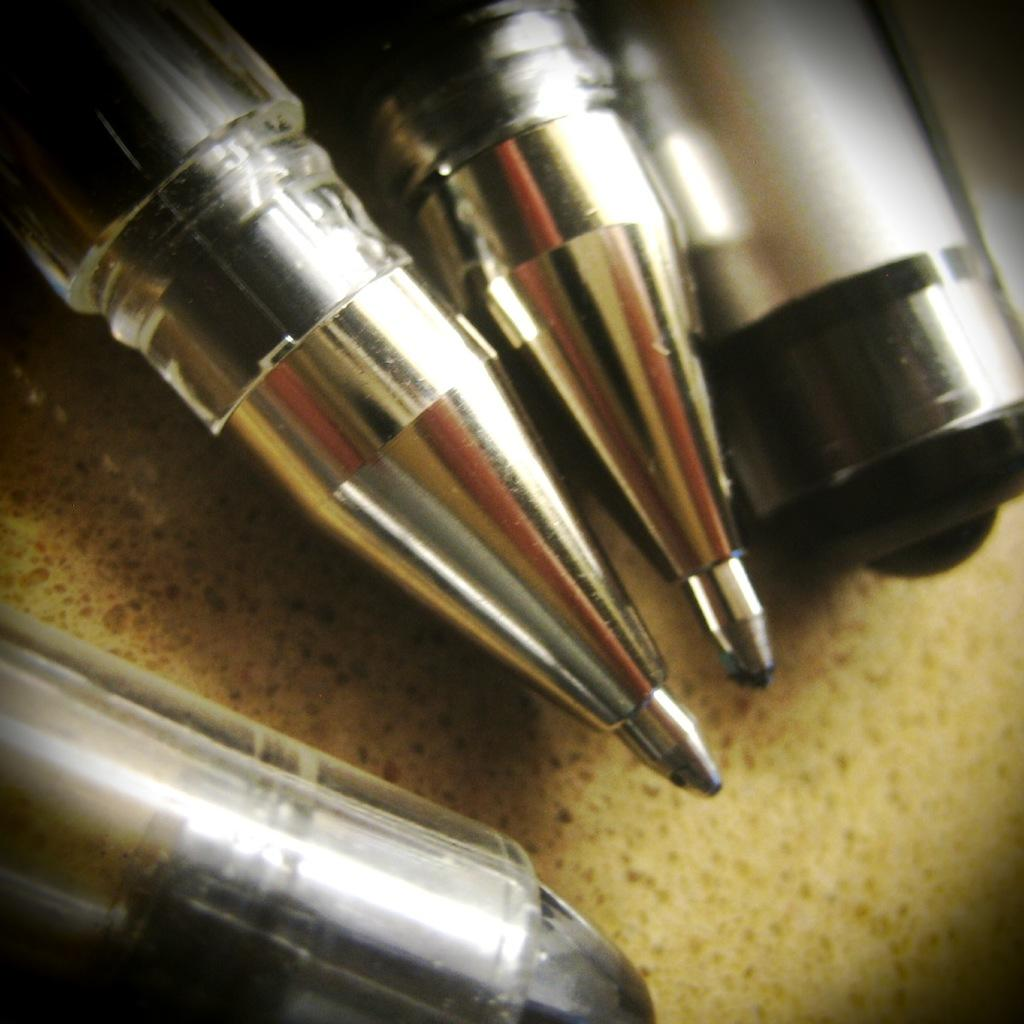What objects are present in the image? There are pens and caps in the image. How are the pens and caps arranged? The pens and caps are arranged on a surface. What can be observed about the background of the image? The background of the image is dark in color. Is the maid wearing a cap in the image? There is no maid or any person present in the image; it only features pens and caps arranged on a surface. 